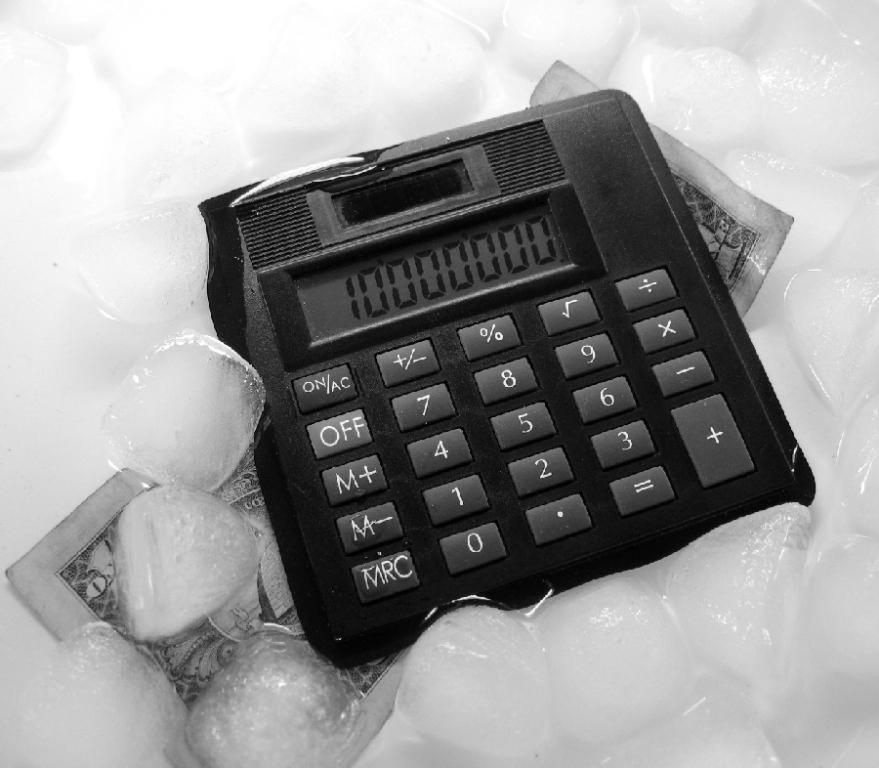<image>
Create a compact narrative representing the image presented. The calculator has the number 10000000 added in onto it. 